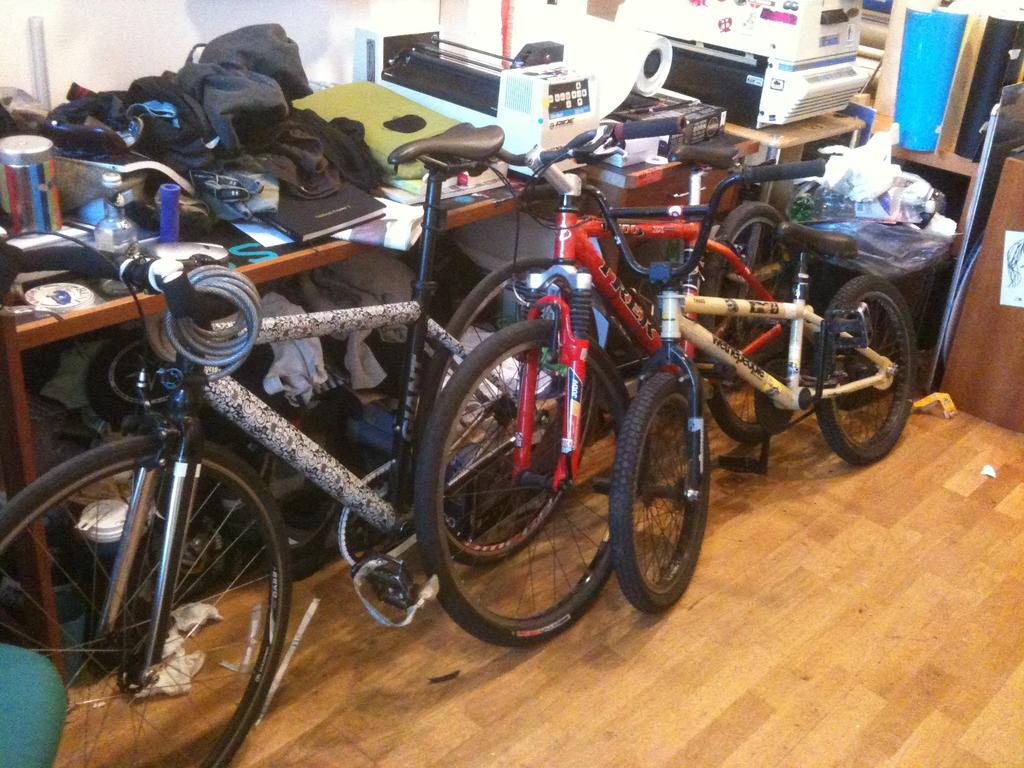What can be seen on the wooden surface in the image? There are bicycles on a wooden surface in the image. What is visible in the background of the image? There is a tablecloth, objects, machines, and other things visible in the background of the image. What type of sheet is being used as a hammock for the bicycles in the image? There is no sheet being used as a hammock for the bicycles in the image. The bicycles are simply placed on a wooden surface. 